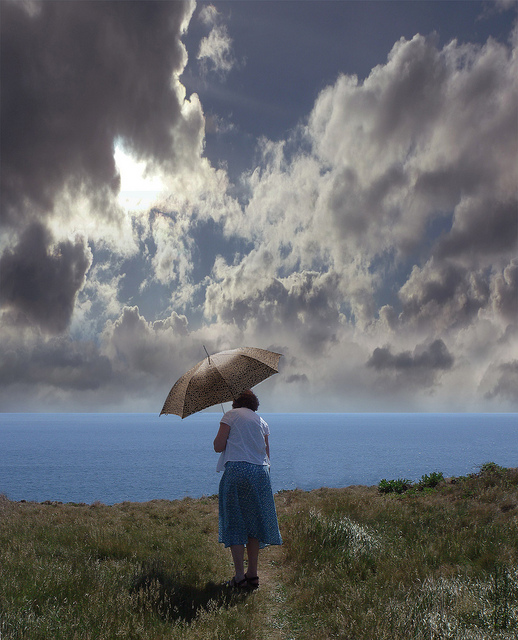<image>What color are the pants? There are no pants in the image. However, if there are, they could be blue. What color are the pants? I don't know what color the pants are. There are different answers given, such as 'blue', 'none', 'no pants', and "those aren't pants". 